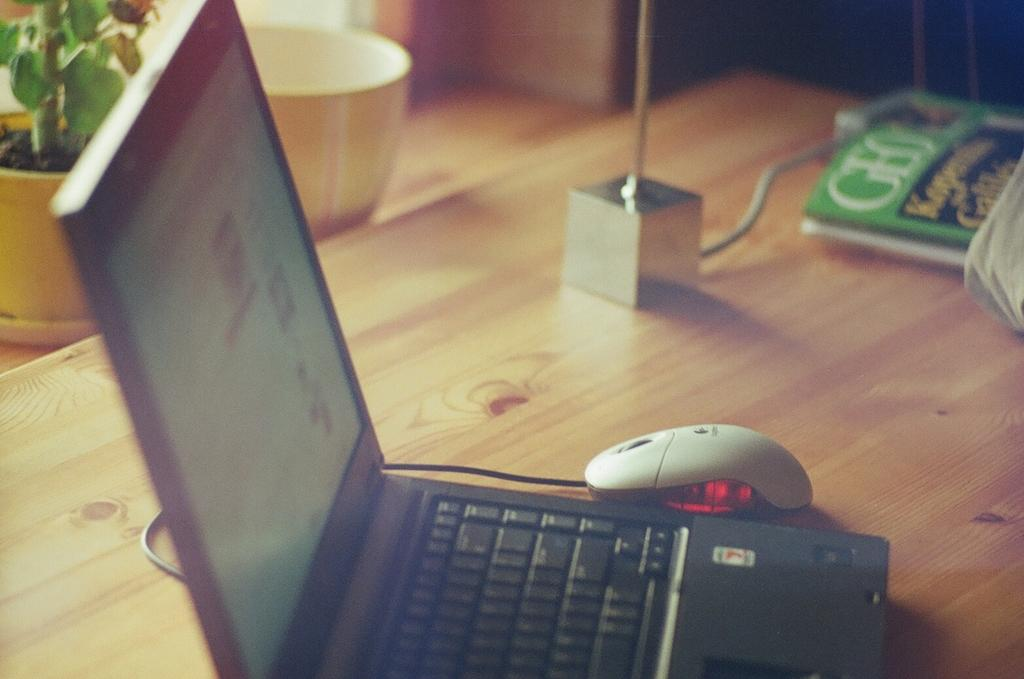What electronic device is visible in the image? There is a laptop in the image. What is used to interact with the laptop? There is a mouse in the image. What type of items can be seen on the table? There are books on the table. What is the color of the paper in the book? The book has green color paper. What objects are located to the side of the table? There is a flower pot and a bowl to the side of the table. Is there a volcano erupting in the image? No, there is no volcano present in the image. What happens if someone tries to smash the laptop in the image? The image does not show anyone attempting to smash the laptop, so it cannot be determined what would happen. 